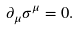Convert formula to latex. <formula><loc_0><loc_0><loc_500><loc_500>\partial _ { \mu } \sigma ^ { \mu } = 0 .</formula> 